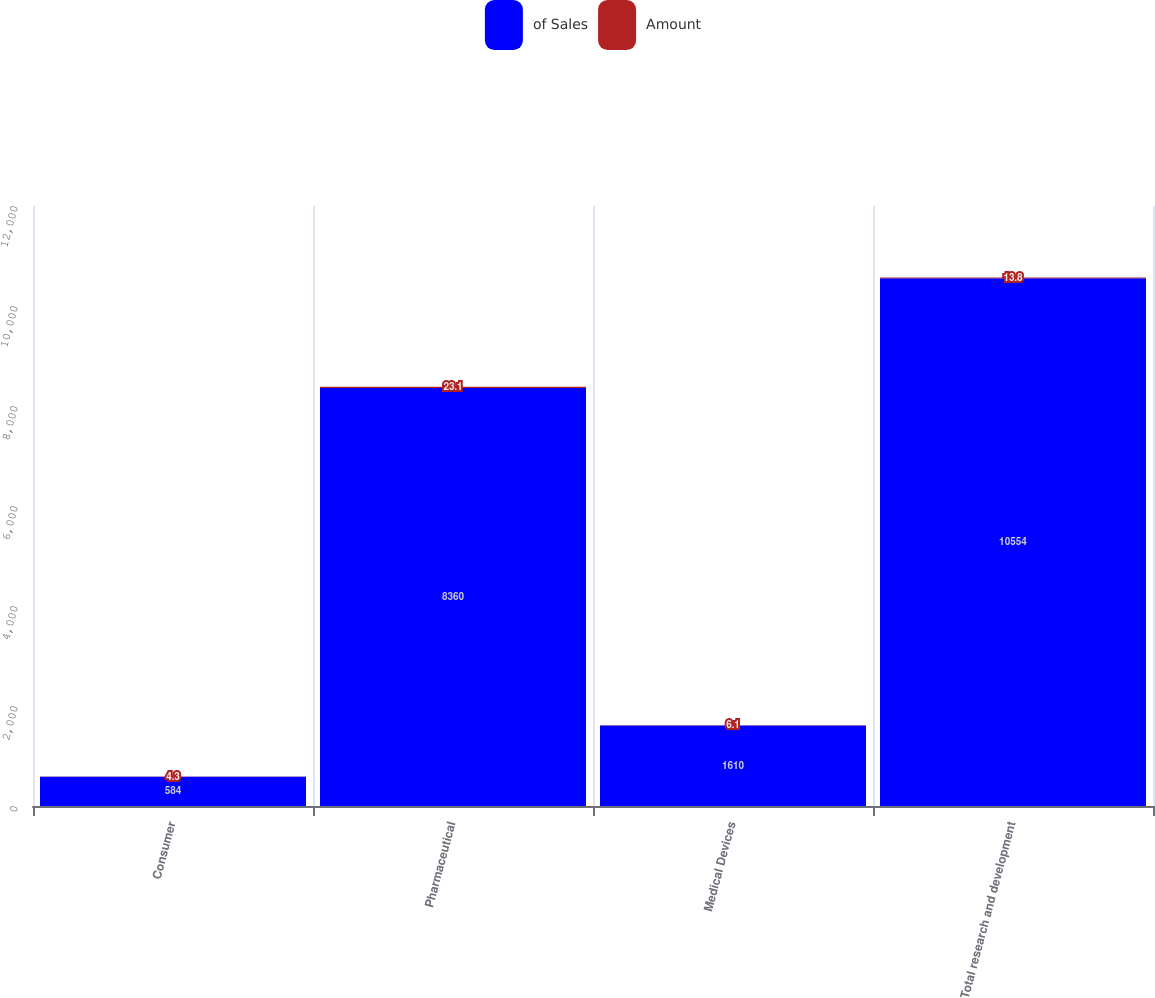Convert chart. <chart><loc_0><loc_0><loc_500><loc_500><stacked_bar_chart><ecel><fcel>Consumer<fcel>Pharmaceutical<fcel>Medical Devices<fcel>Total research and development<nl><fcel>of Sales<fcel>584<fcel>8360<fcel>1610<fcel>10554<nl><fcel>Amount<fcel>4.3<fcel>23.1<fcel>6.1<fcel>13.8<nl></chart> 